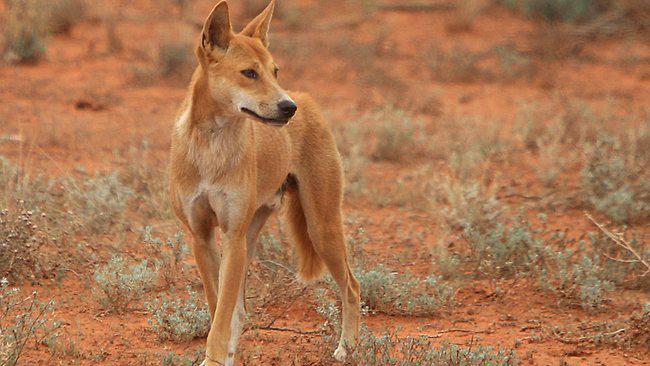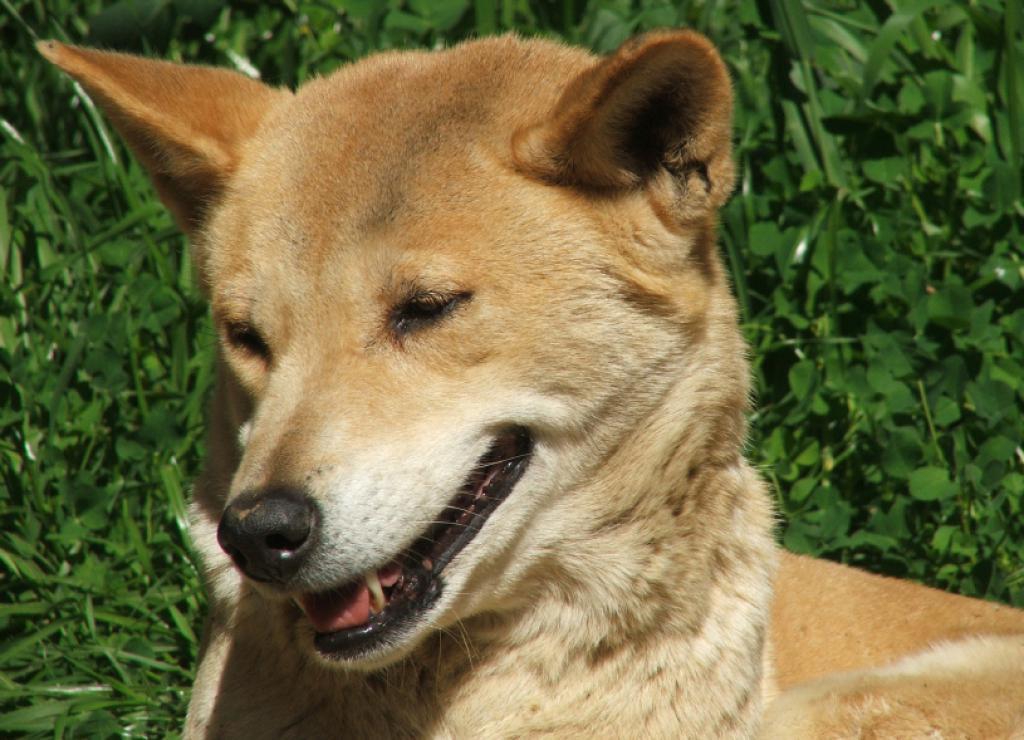The first image is the image on the left, the second image is the image on the right. For the images displayed, is the sentence "A dingo is walking on red dirt in one image." factually correct? Answer yes or no. Yes. The first image is the image on the left, the second image is the image on the right. Considering the images on both sides, is "In at least one image a lone dog on a red sand surface" valid? Answer yes or no. Yes. 